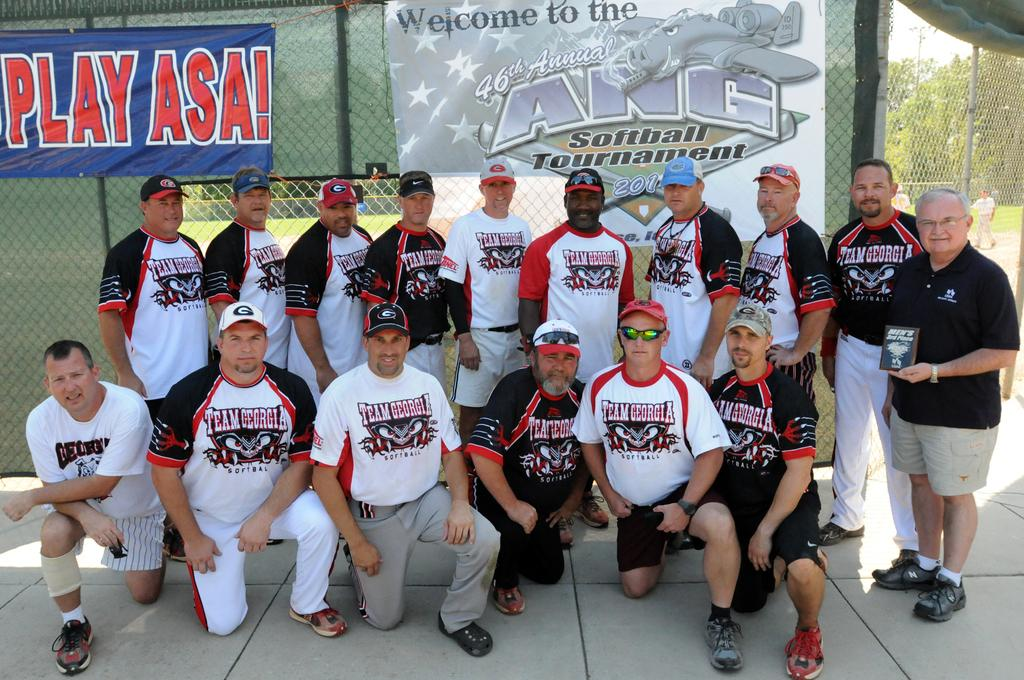<image>
Write a terse but informative summary of the picture. A group of men posing for a photo with Team Georgia on their shirts 